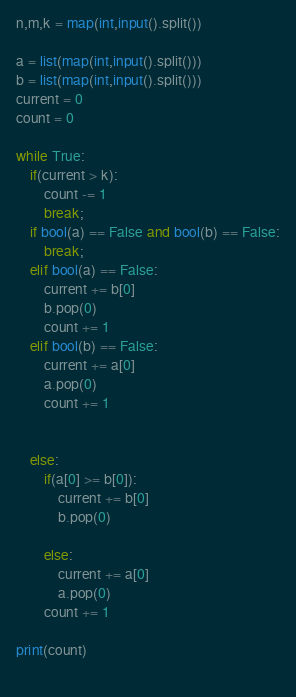<code> <loc_0><loc_0><loc_500><loc_500><_Python_>n,m,k = map(int,input().split())

a = list(map(int,input().split()))
b = list(map(int,input().split()))
current = 0
count = 0

while True:
    if(current > k):
        count -= 1
        break;
    if bool(a) == False and bool(b) == False:
        break;
    elif bool(a) == False:
        current += b[0]
        b.pop(0)
        count += 1
    elif bool(b) == False:
        current += a[0]
        a.pop(0)
        count += 1

    
    else:
        if(a[0] >= b[0]):
            current += b[0]
            b.pop(0)
            
        else:
            current += a[0]
            a.pop(0)
        count += 1

print(count)
        
</code> 